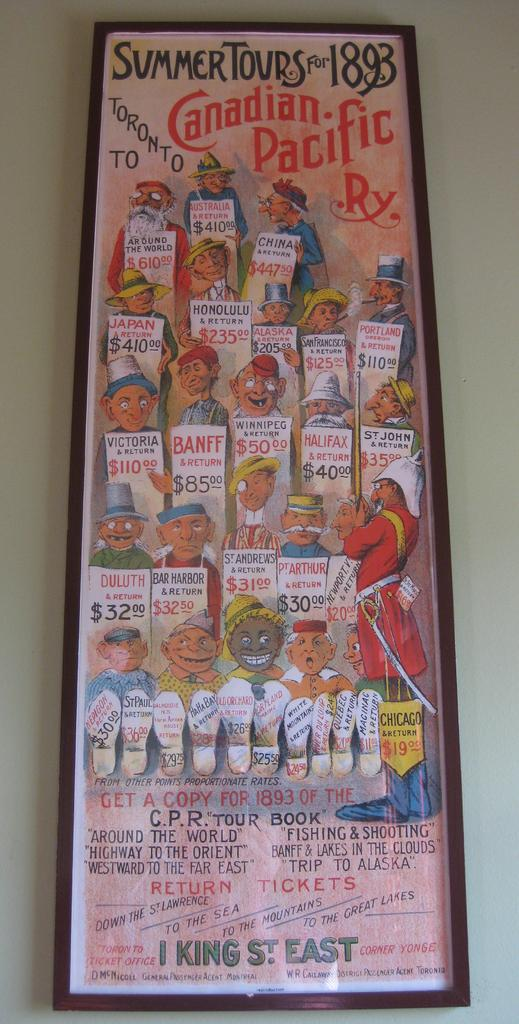What is the main object in the image? There is a frame in the image. How is the frame positioned in the image? The frame is stuck to the wall. What is inside the frame? The frame contains text and animated pictures of people. What type of surface is the frame attached to? There is a wall in the image. Can you see a dog playing in the garden in the image? There is no dog or garden present in the image; it features a frame with text and animated pictures of people. 